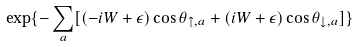Convert formula to latex. <formula><loc_0><loc_0><loc_500><loc_500>\exp \{ - \sum _ { a } [ ( - i W + \epsilon ) \cos \theta _ { \uparrow , a } + ( i W + \epsilon ) \cos \theta _ { \downarrow , a } ] \}</formula> 